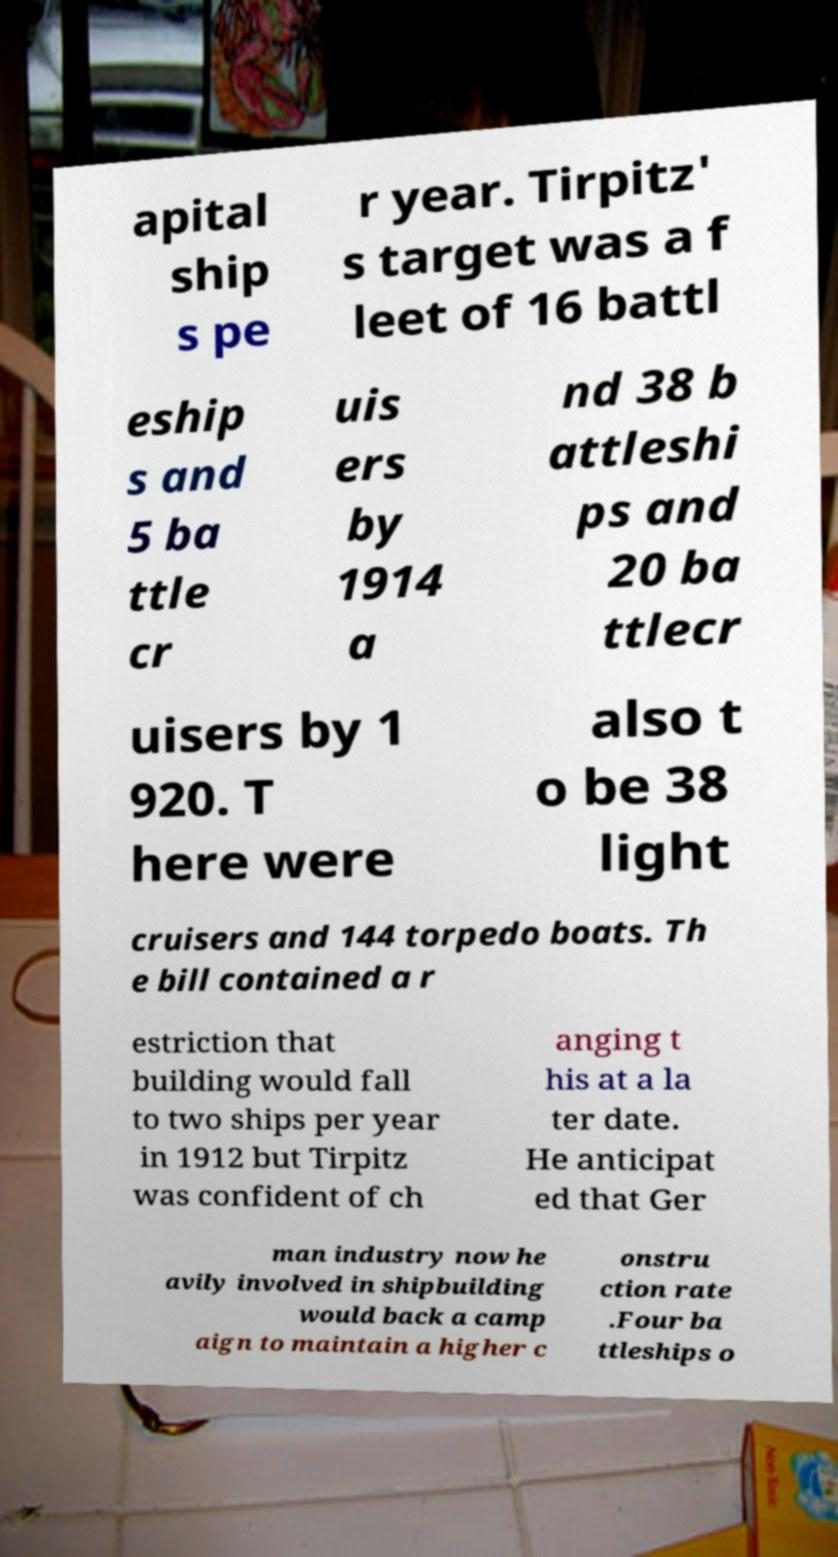Can you read and provide the text displayed in the image?This photo seems to have some interesting text. Can you extract and type it out for me? apital ship s pe r year. Tirpitz' s target was a f leet of 16 battl eship s and 5 ba ttle cr uis ers by 1914 a nd 38 b attleshi ps and 20 ba ttlecr uisers by 1 920. T here were also t o be 38 light cruisers and 144 torpedo boats. Th e bill contained a r estriction that building would fall to two ships per year in 1912 but Tirpitz was confident of ch anging t his at a la ter date. He anticipat ed that Ger man industry now he avily involved in shipbuilding would back a camp aign to maintain a higher c onstru ction rate .Four ba ttleships o 